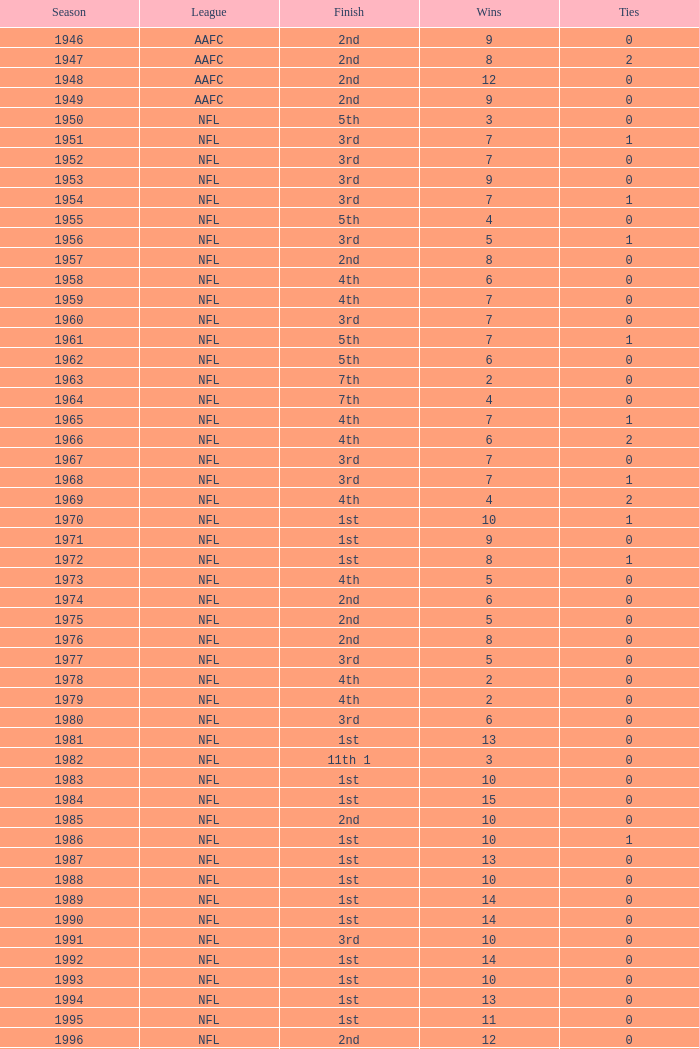Can you parse all the data within this table? {'header': ['Season', 'League', 'Finish', 'Wins', 'Ties'], 'rows': [['1946', 'AAFC', '2nd', '9', '0'], ['1947', 'AAFC', '2nd', '8', '2'], ['1948', 'AAFC', '2nd', '12', '0'], ['1949', 'AAFC', '2nd', '9', '0'], ['1950', 'NFL', '5th', '3', '0'], ['1951', 'NFL', '3rd', '7', '1'], ['1952', 'NFL', '3rd', '7', '0'], ['1953', 'NFL', '3rd', '9', '0'], ['1954', 'NFL', '3rd', '7', '1'], ['1955', 'NFL', '5th', '4', '0'], ['1956', 'NFL', '3rd', '5', '1'], ['1957', 'NFL', '2nd', '8', '0'], ['1958', 'NFL', '4th', '6', '0'], ['1959', 'NFL', '4th', '7', '0'], ['1960', 'NFL', '3rd', '7', '0'], ['1961', 'NFL', '5th', '7', '1'], ['1962', 'NFL', '5th', '6', '0'], ['1963', 'NFL', '7th', '2', '0'], ['1964', 'NFL', '7th', '4', '0'], ['1965', 'NFL', '4th', '7', '1'], ['1966', 'NFL', '4th', '6', '2'], ['1967', 'NFL', '3rd', '7', '0'], ['1968', 'NFL', '3rd', '7', '1'], ['1969', 'NFL', '4th', '4', '2'], ['1970', 'NFL', '1st', '10', '1'], ['1971', 'NFL', '1st', '9', '0'], ['1972', 'NFL', '1st', '8', '1'], ['1973', 'NFL', '4th', '5', '0'], ['1974', 'NFL', '2nd', '6', '0'], ['1975', 'NFL', '2nd', '5', '0'], ['1976', 'NFL', '2nd', '8', '0'], ['1977', 'NFL', '3rd', '5', '0'], ['1978', 'NFL', '4th', '2', '0'], ['1979', 'NFL', '4th', '2', '0'], ['1980', 'NFL', '3rd', '6', '0'], ['1981', 'NFL', '1st', '13', '0'], ['1982', 'NFL', '11th 1', '3', '0'], ['1983', 'NFL', '1st', '10', '0'], ['1984', 'NFL', '1st', '15', '0'], ['1985', 'NFL', '2nd', '10', '0'], ['1986', 'NFL', '1st', '10', '1'], ['1987', 'NFL', '1st', '13', '0'], ['1988', 'NFL', '1st', '10', '0'], ['1989', 'NFL', '1st', '14', '0'], ['1990', 'NFL', '1st', '14', '0'], ['1991', 'NFL', '3rd', '10', '0'], ['1992', 'NFL', '1st', '14', '0'], ['1993', 'NFL', '1st', '10', '0'], ['1994', 'NFL', '1st', '13', '0'], ['1995', 'NFL', '1st', '11', '0'], ['1996', 'NFL', '2nd', '12', '0'], ['1997', 'NFL', '1st', '13', '0'], ['1998', 'NFL', '2nd', '12', '0'], ['1999', 'NFL', '4th', '4', '0'], ['2000', 'NFL', '4th', '6', '0'], ['2001', 'NFL', '2nd', '12', '0'], ['2002', 'NFL', '1st', '10', '0'], ['2003', 'NFL', '3rd', '7', '0'], ['2004', 'NFL', '4th', '2', '0'], ['2005', 'NFL', '4th', '4', '0'], ['2006', 'NFL', '3rd', '7', '0'], ['2007', 'NFL', '3rd', '5', '0'], ['2008', 'NFL', '2nd', '7', '0'], ['2009', 'NFL', '2nd', '8', '0'], ['2010', 'NFL', '3rd', '6', '0'], ['2011', 'NFL', '1st', '13', '0'], ['2012', 'NFL', '1st', '11', '1'], ['2013', 'NFL', '2nd', '6', '0']]} What is the lowest number of ties in the NFL, with less than 2 losses and less than 15 wins? None. 